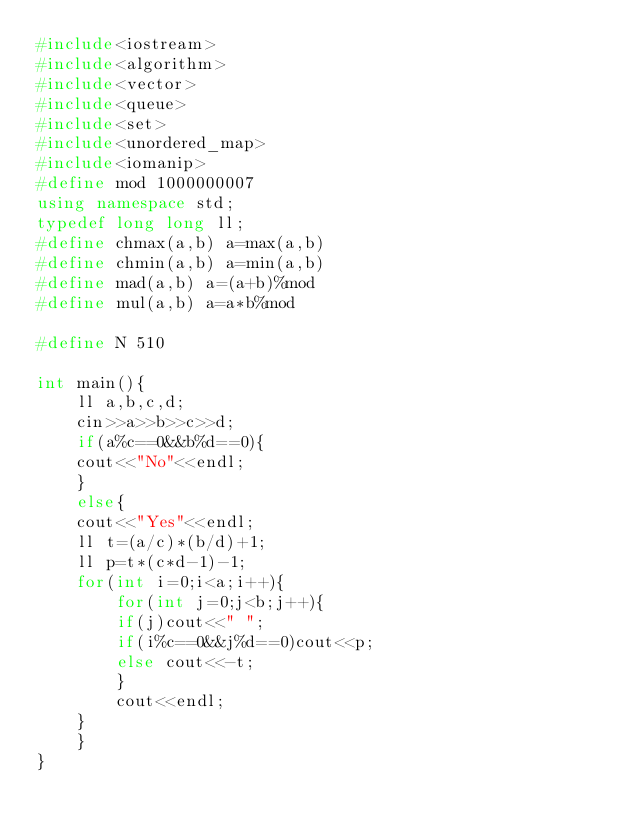Convert code to text. <code><loc_0><loc_0><loc_500><loc_500><_C++_>#include<iostream>
#include<algorithm>
#include<vector>
#include<queue>
#include<set>
#include<unordered_map>
#include<iomanip>
#define mod 1000000007
using namespace std;
typedef long long ll;
#define chmax(a,b) a=max(a,b)
#define chmin(a,b) a=min(a,b)
#define mad(a,b) a=(a+b)%mod
#define mul(a,b) a=a*b%mod

#define N 510

int main(){
    ll a,b,c,d;
    cin>>a>>b>>c>>d;
    if(a%c==0&&b%d==0){
	cout<<"No"<<endl;
    }
    else{
	cout<<"Yes"<<endl;
	ll t=(a/c)*(b/d)+1;
	ll p=t*(c*d-1)-1;
	for(int i=0;i<a;i++){
	    for(int j=0;j<b;j++){
		if(j)cout<<" ";
		if(i%c==0&&j%d==0)cout<<p;
		else cout<<-t;
	    }
	    cout<<endl;
	}
    }
}

</code> 